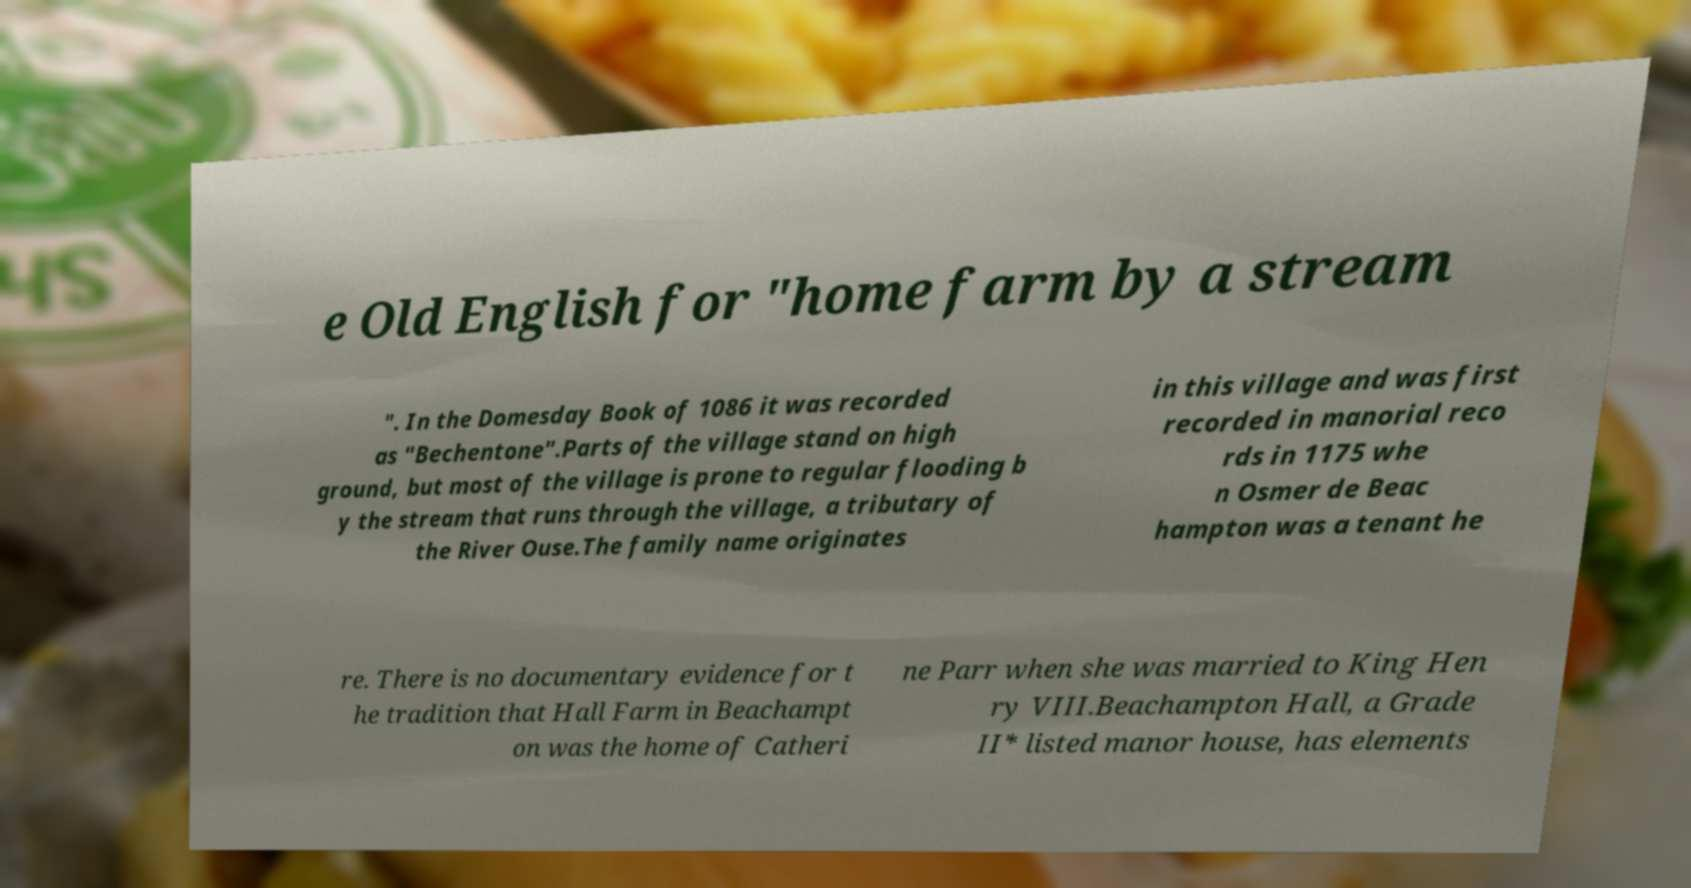I need the written content from this picture converted into text. Can you do that? e Old English for "home farm by a stream ". In the Domesday Book of 1086 it was recorded as "Bechentone".Parts of the village stand on high ground, but most of the village is prone to regular flooding b y the stream that runs through the village, a tributary of the River Ouse.The family name originates in this village and was first recorded in manorial reco rds in 1175 whe n Osmer de Beac hampton was a tenant he re. There is no documentary evidence for t he tradition that Hall Farm in Beachampt on was the home of Catheri ne Parr when she was married to King Hen ry VIII.Beachampton Hall, a Grade II* listed manor house, has elements 